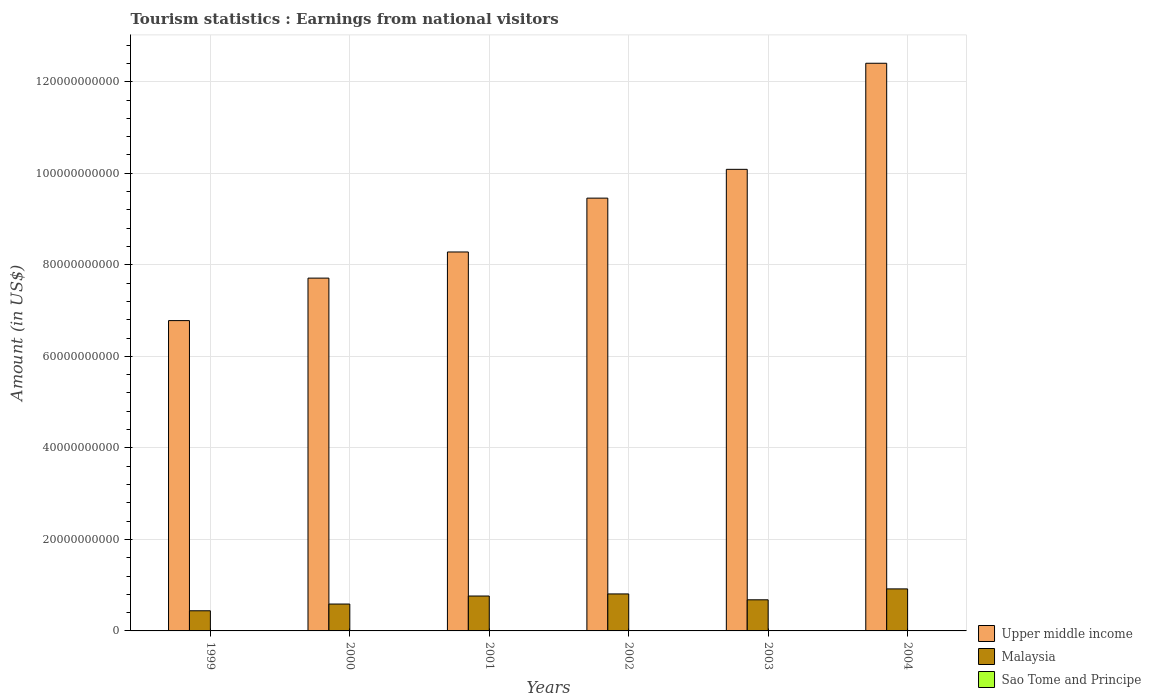How many different coloured bars are there?
Keep it short and to the point. 3. How many groups of bars are there?
Your response must be concise. 6. Are the number of bars per tick equal to the number of legend labels?
Provide a succinct answer. Yes. How many bars are there on the 6th tick from the left?
Ensure brevity in your answer.  3. What is the label of the 6th group of bars from the left?
Give a very brief answer. 2004. What is the earnings from national visitors in Upper middle income in 2000?
Offer a very short reply. 7.71e+1. Across all years, what is the maximum earnings from national visitors in Sao Tome and Principe?
Make the answer very short. 9.90e+06. Across all years, what is the minimum earnings from national visitors in Malaysia?
Your answer should be compact. 4.40e+09. What is the total earnings from national visitors in Malaysia in the graph?
Keep it short and to the point. 4.20e+1. What is the difference between the earnings from national visitors in Sao Tome and Principe in 2001 and that in 2003?
Make the answer very short. -1.20e+06. What is the difference between the earnings from national visitors in Sao Tome and Principe in 2000 and the earnings from national visitors in Upper middle income in 2002?
Your answer should be compact. -9.46e+1. What is the average earnings from national visitors in Upper middle income per year?
Provide a short and direct response. 9.12e+1. In the year 1999, what is the difference between the earnings from national visitors in Sao Tome and Principe and earnings from national visitors in Upper middle income?
Offer a very short reply. -6.78e+1. In how many years, is the earnings from national visitors in Upper middle income greater than 52000000000 US$?
Offer a very short reply. 6. What is the ratio of the earnings from national visitors in Upper middle income in 2001 to that in 2004?
Your answer should be very brief. 0.67. What is the difference between the highest and the second highest earnings from national visitors in Upper middle income?
Provide a succinct answer. 2.32e+1. What is the difference between the highest and the lowest earnings from national visitors in Malaysia?
Your response must be concise. 4.78e+09. In how many years, is the earnings from national visitors in Upper middle income greater than the average earnings from national visitors in Upper middle income taken over all years?
Ensure brevity in your answer.  3. What does the 2nd bar from the left in 2001 represents?
Give a very brief answer. Malaysia. What does the 1st bar from the right in 2000 represents?
Offer a very short reply. Sao Tome and Principe. Are all the bars in the graph horizontal?
Keep it short and to the point. No. Does the graph contain grids?
Keep it short and to the point. Yes. What is the title of the graph?
Offer a very short reply. Tourism statistics : Earnings from national visitors. What is the label or title of the X-axis?
Make the answer very short. Years. What is the Amount (in US$) in Upper middle income in 1999?
Keep it short and to the point. 6.78e+1. What is the Amount (in US$) in Malaysia in 1999?
Keep it short and to the point. 4.40e+09. What is the Amount (in US$) of Sao Tome and Principe in 1999?
Ensure brevity in your answer.  9.20e+06. What is the Amount (in US$) of Upper middle income in 2000?
Keep it short and to the point. 7.71e+1. What is the Amount (in US$) of Malaysia in 2000?
Ensure brevity in your answer.  5.87e+09. What is the Amount (in US$) of Sao Tome and Principe in 2000?
Offer a terse response. 9.90e+06. What is the Amount (in US$) of Upper middle income in 2001?
Your answer should be compact. 8.28e+1. What is the Amount (in US$) of Malaysia in 2001?
Provide a succinct answer. 7.63e+09. What is the Amount (in US$) in Sao Tome and Principe in 2001?
Your response must be concise. 6.20e+06. What is the Amount (in US$) of Upper middle income in 2002?
Offer a very short reply. 9.46e+1. What is the Amount (in US$) of Malaysia in 2002?
Ensure brevity in your answer.  8.08e+09. What is the Amount (in US$) of Sao Tome and Principe in 2002?
Ensure brevity in your answer.  6.90e+06. What is the Amount (in US$) in Upper middle income in 2003?
Ensure brevity in your answer.  1.01e+11. What is the Amount (in US$) in Malaysia in 2003?
Make the answer very short. 6.80e+09. What is the Amount (in US$) of Sao Tome and Principe in 2003?
Give a very brief answer. 7.40e+06. What is the Amount (in US$) in Upper middle income in 2004?
Keep it short and to the point. 1.24e+11. What is the Amount (in US$) of Malaysia in 2004?
Provide a short and direct response. 9.18e+09. What is the Amount (in US$) in Sao Tome and Principe in 2004?
Your answer should be very brief. 7.70e+06. Across all years, what is the maximum Amount (in US$) of Upper middle income?
Provide a succinct answer. 1.24e+11. Across all years, what is the maximum Amount (in US$) of Malaysia?
Your answer should be compact. 9.18e+09. Across all years, what is the maximum Amount (in US$) in Sao Tome and Principe?
Ensure brevity in your answer.  9.90e+06. Across all years, what is the minimum Amount (in US$) in Upper middle income?
Provide a short and direct response. 6.78e+1. Across all years, what is the minimum Amount (in US$) in Malaysia?
Give a very brief answer. 4.40e+09. Across all years, what is the minimum Amount (in US$) in Sao Tome and Principe?
Offer a very short reply. 6.20e+06. What is the total Amount (in US$) of Upper middle income in the graph?
Offer a very short reply. 5.47e+11. What is the total Amount (in US$) of Malaysia in the graph?
Your answer should be very brief. 4.20e+1. What is the total Amount (in US$) in Sao Tome and Principe in the graph?
Provide a short and direct response. 4.73e+07. What is the difference between the Amount (in US$) in Upper middle income in 1999 and that in 2000?
Keep it short and to the point. -9.29e+09. What is the difference between the Amount (in US$) in Malaysia in 1999 and that in 2000?
Make the answer very short. -1.47e+09. What is the difference between the Amount (in US$) in Sao Tome and Principe in 1999 and that in 2000?
Offer a terse response. -7.00e+05. What is the difference between the Amount (in US$) in Upper middle income in 1999 and that in 2001?
Your answer should be compact. -1.50e+1. What is the difference between the Amount (in US$) in Malaysia in 1999 and that in 2001?
Keep it short and to the point. -3.22e+09. What is the difference between the Amount (in US$) of Sao Tome and Principe in 1999 and that in 2001?
Provide a short and direct response. 3.00e+06. What is the difference between the Amount (in US$) of Upper middle income in 1999 and that in 2002?
Make the answer very short. -2.68e+1. What is the difference between the Amount (in US$) in Malaysia in 1999 and that in 2002?
Give a very brief answer. -3.68e+09. What is the difference between the Amount (in US$) in Sao Tome and Principe in 1999 and that in 2002?
Your answer should be very brief. 2.30e+06. What is the difference between the Amount (in US$) of Upper middle income in 1999 and that in 2003?
Keep it short and to the point. -3.31e+1. What is the difference between the Amount (in US$) in Malaysia in 1999 and that in 2003?
Provide a short and direct response. -2.40e+09. What is the difference between the Amount (in US$) in Sao Tome and Principe in 1999 and that in 2003?
Offer a very short reply. 1.80e+06. What is the difference between the Amount (in US$) in Upper middle income in 1999 and that in 2004?
Keep it short and to the point. -5.62e+1. What is the difference between the Amount (in US$) in Malaysia in 1999 and that in 2004?
Provide a short and direct response. -4.78e+09. What is the difference between the Amount (in US$) of Sao Tome and Principe in 1999 and that in 2004?
Your answer should be very brief. 1.50e+06. What is the difference between the Amount (in US$) in Upper middle income in 2000 and that in 2001?
Provide a short and direct response. -5.71e+09. What is the difference between the Amount (in US$) in Malaysia in 2000 and that in 2001?
Give a very brief answer. -1.75e+09. What is the difference between the Amount (in US$) of Sao Tome and Principe in 2000 and that in 2001?
Provide a short and direct response. 3.70e+06. What is the difference between the Amount (in US$) of Upper middle income in 2000 and that in 2002?
Your answer should be compact. -1.75e+1. What is the difference between the Amount (in US$) of Malaysia in 2000 and that in 2002?
Your answer should be compact. -2.21e+09. What is the difference between the Amount (in US$) in Upper middle income in 2000 and that in 2003?
Your response must be concise. -2.38e+1. What is the difference between the Amount (in US$) of Malaysia in 2000 and that in 2003?
Offer a very short reply. -9.26e+08. What is the difference between the Amount (in US$) of Sao Tome and Principe in 2000 and that in 2003?
Offer a very short reply. 2.50e+06. What is the difference between the Amount (in US$) of Upper middle income in 2000 and that in 2004?
Keep it short and to the point. -4.70e+1. What is the difference between the Amount (in US$) in Malaysia in 2000 and that in 2004?
Give a very brief answer. -3.31e+09. What is the difference between the Amount (in US$) in Sao Tome and Principe in 2000 and that in 2004?
Ensure brevity in your answer.  2.20e+06. What is the difference between the Amount (in US$) in Upper middle income in 2001 and that in 2002?
Provide a succinct answer. -1.18e+1. What is the difference between the Amount (in US$) of Malaysia in 2001 and that in 2002?
Ensure brevity in your answer.  -4.57e+08. What is the difference between the Amount (in US$) of Sao Tome and Principe in 2001 and that in 2002?
Keep it short and to the point. -7.00e+05. What is the difference between the Amount (in US$) of Upper middle income in 2001 and that in 2003?
Offer a very short reply. -1.81e+1. What is the difference between the Amount (in US$) in Malaysia in 2001 and that in 2003?
Your answer should be very brief. 8.28e+08. What is the difference between the Amount (in US$) of Sao Tome and Principe in 2001 and that in 2003?
Your answer should be compact. -1.20e+06. What is the difference between the Amount (in US$) in Upper middle income in 2001 and that in 2004?
Ensure brevity in your answer.  -4.12e+1. What is the difference between the Amount (in US$) of Malaysia in 2001 and that in 2004?
Provide a short and direct response. -1.56e+09. What is the difference between the Amount (in US$) in Sao Tome and Principe in 2001 and that in 2004?
Your answer should be compact. -1.50e+06. What is the difference between the Amount (in US$) in Upper middle income in 2002 and that in 2003?
Your response must be concise. -6.29e+09. What is the difference between the Amount (in US$) of Malaysia in 2002 and that in 2003?
Offer a terse response. 1.28e+09. What is the difference between the Amount (in US$) in Sao Tome and Principe in 2002 and that in 2003?
Offer a very short reply. -5.00e+05. What is the difference between the Amount (in US$) of Upper middle income in 2002 and that in 2004?
Ensure brevity in your answer.  -2.95e+1. What is the difference between the Amount (in US$) of Malaysia in 2002 and that in 2004?
Ensure brevity in your answer.  -1.10e+09. What is the difference between the Amount (in US$) in Sao Tome and Principe in 2002 and that in 2004?
Provide a succinct answer. -8.00e+05. What is the difference between the Amount (in US$) in Upper middle income in 2003 and that in 2004?
Your answer should be very brief. -2.32e+1. What is the difference between the Amount (in US$) of Malaysia in 2003 and that in 2004?
Make the answer very short. -2.38e+09. What is the difference between the Amount (in US$) of Sao Tome and Principe in 2003 and that in 2004?
Your answer should be very brief. -3.00e+05. What is the difference between the Amount (in US$) in Upper middle income in 1999 and the Amount (in US$) in Malaysia in 2000?
Provide a succinct answer. 6.19e+1. What is the difference between the Amount (in US$) in Upper middle income in 1999 and the Amount (in US$) in Sao Tome and Principe in 2000?
Your answer should be compact. 6.78e+1. What is the difference between the Amount (in US$) in Malaysia in 1999 and the Amount (in US$) in Sao Tome and Principe in 2000?
Offer a terse response. 4.39e+09. What is the difference between the Amount (in US$) of Upper middle income in 1999 and the Amount (in US$) of Malaysia in 2001?
Your answer should be compact. 6.02e+1. What is the difference between the Amount (in US$) in Upper middle income in 1999 and the Amount (in US$) in Sao Tome and Principe in 2001?
Your response must be concise. 6.78e+1. What is the difference between the Amount (in US$) of Malaysia in 1999 and the Amount (in US$) of Sao Tome and Principe in 2001?
Give a very brief answer. 4.40e+09. What is the difference between the Amount (in US$) in Upper middle income in 1999 and the Amount (in US$) in Malaysia in 2002?
Your answer should be very brief. 5.97e+1. What is the difference between the Amount (in US$) in Upper middle income in 1999 and the Amount (in US$) in Sao Tome and Principe in 2002?
Make the answer very short. 6.78e+1. What is the difference between the Amount (in US$) of Malaysia in 1999 and the Amount (in US$) of Sao Tome and Principe in 2002?
Your answer should be compact. 4.40e+09. What is the difference between the Amount (in US$) in Upper middle income in 1999 and the Amount (in US$) in Malaysia in 2003?
Offer a very short reply. 6.10e+1. What is the difference between the Amount (in US$) of Upper middle income in 1999 and the Amount (in US$) of Sao Tome and Principe in 2003?
Your response must be concise. 6.78e+1. What is the difference between the Amount (in US$) in Malaysia in 1999 and the Amount (in US$) in Sao Tome and Principe in 2003?
Make the answer very short. 4.40e+09. What is the difference between the Amount (in US$) of Upper middle income in 1999 and the Amount (in US$) of Malaysia in 2004?
Ensure brevity in your answer.  5.86e+1. What is the difference between the Amount (in US$) of Upper middle income in 1999 and the Amount (in US$) of Sao Tome and Principe in 2004?
Your answer should be very brief. 6.78e+1. What is the difference between the Amount (in US$) of Malaysia in 1999 and the Amount (in US$) of Sao Tome and Principe in 2004?
Your answer should be very brief. 4.40e+09. What is the difference between the Amount (in US$) of Upper middle income in 2000 and the Amount (in US$) of Malaysia in 2001?
Provide a succinct answer. 6.95e+1. What is the difference between the Amount (in US$) of Upper middle income in 2000 and the Amount (in US$) of Sao Tome and Principe in 2001?
Provide a succinct answer. 7.71e+1. What is the difference between the Amount (in US$) in Malaysia in 2000 and the Amount (in US$) in Sao Tome and Principe in 2001?
Give a very brief answer. 5.87e+09. What is the difference between the Amount (in US$) of Upper middle income in 2000 and the Amount (in US$) of Malaysia in 2002?
Offer a very short reply. 6.90e+1. What is the difference between the Amount (in US$) in Upper middle income in 2000 and the Amount (in US$) in Sao Tome and Principe in 2002?
Give a very brief answer. 7.71e+1. What is the difference between the Amount (in US$) of Malaysia in 2000 and the Amount (in US$) of Sao Tome and Principe in 2002?
Your answer should be compact. 5.87e+09. What is the difference between the Amount (in US$) in Upper middle income in 2000 and the Amount (in US$) in Malaysia in 2003?
Your response must be concise. 7.03e+1. What is the difference between the Amount (in US$) of Upper middle income in 2000 and the Amount (in US$) of Sao Tome and Principe in 2003?
Your answer should be very brief. 7.71e+1. What is the difference between the Amount (in US$) in Malaysia in 2000 and the Amount (in US$) in Sao Tome and Principe in 2003?
Offer a terse response. 5.87e+09. What is the difference between the Amount (in US$) of Upper middle income in 2000 and the Amount (in US$) of Malaysia in 2004?
Your response must be concise. 6.79e+1. What is the difference between the Amount (in US$) of Upper middle income in 2000 and the Amount (in US$) of Sao Tome and Principe in 2004?
Make the answer very short. 7.71e+1. What is the difference between the Amount (in US$) of Malaysia in 2000 and the Amount (in US$) of Sao Tome and Principe in 2004?
Your answer should be very brief. 5.87e+09. What is the difference between the Amount (in US$) in Upper middle income in 2001 and the Amount (in US$) in Malaysia in 2002?
Your answer should be compact. 7.47e+1. What is the difference between the Amount (in US$) in Upper middle income in 2001 and the Amount (in US$) in Sao Tome and Principe in 2002?
Offer a very short reply. 8.28e+1. What is the difference between the Amount (in US$) in Malaysia in 2001 and the Amount (in US$) in Sao Tome and Principe in 2002?
Provide a succinct answer. 7.62e+09. What is the difference between the Amount (in US$) in Upper middle income in 2001 and the Amount (in US$) in Malaysia in 2003?
Offer a terse response. 7.60e+1. What is the difference between the Amount (in US$) in Upper middle income in 2001 and the Amount (in US$) in Sao Tome and Principe in 2003?
Provide a succinct answer. 8.28e+1. What is the difference between the Amount (in US$) of Malaysia in 2001 and the Amount (in US$) of Sao Tome and Principe in 2003?
Your answer should be compact. 7.62e+09. What is the difference between the Amount (in US$) of Upper middle income in 2001 and the Amount (in US$) of Malaysia in 2004?
Give a very brief answer. 7.36e+1. What is the difference between the Amount (in US$) in Upper middle income in 2001 and the Amount (in US$) in Sao Tome and Principe in 2004?
Provide a short and direct response. 8.28e+1. What is the difference between the Amount (in US$) of Malaysia in 2001 and the Amount (in US$) of Sao Tome and Principe in 2004?
Provide a short and direct response. 7.62e+09. What is the difference between the Amount (in US$) in Upper middle income in 2002 and the Amount (in US$) in Malaysia in 2003?
Offer a very short reply. 8.78e+1. What is the difference between the Amount (in US$) of Upper middle income in 2002 and the Amount (in US$) of Sao Tome and Principe in 2003?
Ensure brevity in your answer.  9.46e+1. What is the difference between the Amount (in US$) of Malaysia in 2002 and the Amount (in US$) of Sao Tome and Principe in 2003?
Make the answer very short. 8.08e+09. What is the difference between the Amount (in US$) of Upper middle income in 2002 and the Amount (in US$) of Malaysia in 2004?
Provide a succinct answer. 8.54e+1. What is the difference between the Amount (in US$) in Upper middle income in 2002 and the Amount (in US$) in Sao Tome and Principe in 2004?
Provide a short and direct response. 9.46e+1. What is the difference between the Amount (in US$) in Malaysia in 2002 and the Amount (in US$) in Sao Tome and Principe in 2004?
Offer a terse response. 8.08e+09. What is the difference between the Amount (in US$) in Upper middle income in 2003 and the Amount (in US$) in Malaysia in 2004?
Keep it short and to the point. 9.17e+1. What is the difference between the Amount (in US$) in Upper middle income in 2003 and the Amount (in US$) in Sao Tome and Principe in 2004?
Provide a succinct answer. 1.01e+11. What is the difference between the Amount (in US$) of Malaysia in 2003 and the Amount (in US$) of Sao Tome and Principe in 2004?
Offer a very short reply. 6.79e+09. What is the average Amount (in US$) in Upper middle income per year?
Provide a short and direct response. 9.12e+1. What is the average Amount (in US$) in Malaysia per year?
Your response must be concise. 6.99e+09. What is the average Amount (in US$) of Sao Tome and Principe per year?
Your answer should be very brief. 7.88e+06. In the year 1999, what is the difference between the Amount (in US$) of Upper middle income and Amount (in US$) of Malaysia?
Keep it short and to the point. 6.34e+1. In the year 1999, what is the difference between the Amount (in US$) in Upper middle income and Amount (in US$) in Sao Tome and Principe?
Provide a short and direct response. 6.78e+1. In the year 1999, what is the difference between the Amount (in US$) of Malaysia and Amount (in US$) of Sao Tome and Principe?
Offer a terse response. 4.39e+09. In the year 2000, what is the difference between the Amount (in US$) of Upper middle income and Amount (in US$) of Malaysia?
Ensure brevity in your answer.  7.12e+1. In the year 2000, what is the difference between the Amount (in US$) in Upper middle income and Amount (in US$) in Sao Tome and Principe?
Offer a very short reply. 7.71e+1. In the year 2000, what is the difference between the Amount (in US$) of Malaysia and Amount (in US$) of Sao Tome and Principe?
Make the answer very short. 5.86e+09. In the year 2001, what is the difference between the Amount (in US$) in Upper middle income and Amount (in US$) in Malaysia?
Give a very brief answer. 7.52e+1. In the year 2001, what is the difference between the Amount (in US$) of Upper middle income and Amount (in US$) of Sao Tome and Principe?
Keep it short and to the point. 8.28e+1. In the year 2001, what is the difference between the Amount (in US$) of Malaysia and Amount (in US$) of Sao Tome and Principe?
Offer a very short reply. 7.62e+09. In the year 2002, what is the difference between the Amount (in US$) of Upper middle income and Amount (in US$) of Malaysia?
Provide a short and direct response. 8.65e+1. In the year 2002, what is the difference between the Amount (in US$) in Upper middle income and Amount (in US$) in Sao Tome and Principe?
Keep it short and to the point. 9.46e+1. In the year 2002, what is the difference between the Amount (in US$) in Malaysia and Amount (in US$) in Sao Tome and Principe?
Make the answer very short. 8.08e+09. In the year 2003, what is the difference between the Amount (in US$) in Upper middle income and Amount (in US$) in Malaysia?
Your answer should be very brief. 9.41e+1. In the year 2003, what is the difference between the Amount (in US$) of Upper middle income and Amount (in US$) of Sao Tome and Principe?
Make the answer very short. 1.01e+11. In the year 2003, what is the difference between the Amount (in US$) in Malaysia and Amount (in US$) in Sao Tome and Principe?
Make the answer very short. 6.79e+09. In the year 2004, what is the difference between the Amount (in US$) of Upper middle income and Amount (in US$) of Malaysia?
Offer a very short reply. 1.15e+11. In the year 2004, what is the difference between the Amount (in US$) in Upper middle income and Amount (in US$) in Sao Tome and Principe?
Keep it short and to the point. 1.24e+11. In the year 2004, what is the difference between the Amount (in US$) in Malaysia and Amount (in US$) in Sao Tome and Principe?
Give a very brief answer. 9.18e+09. What is the ratio of the Amount (in US$) of Upper middle income in 1999 to that in 2000?
Give a very brief answer. 0.88. What is the ratio of the Amount (in US$) of Malaysia in 1999 to that in 2000?
Offer a terse response. 0.75. What is the ratio of the Amount (in US$) of Sao Tome and Principe in 1999 to that in 2000?
Make the answer very short. 0.93. What is the ratio of the Amount (in US$) of Upper middle income in 1999 to that in 2001?
Offer a very short reply. 0.82. What is the ratio of the Amount (in US$) of Malaysia in 1999 to that in 2001?
Offer a terse response. 0.58. What is the ratio of the Amount (in US$) in Sao Tome and Principe in 1999 to that in 2001?
Offer a terse response. 1.48. What is the ratio of the Amount (in US$) in Upper middle income in 1999 to that in 2002?
Your answer should be very brief. 0.72. What is the ratio of the Amount (in US$) of Malaysia in 1999 to that in 2002?
Offer a very short reply. 0.54. What is the ratio of the Amount (in US$) of Upper middle income in 1999 to that in 2003?
Provide a short and direct response. 0.67. What is the ratio of the Amount (in US$) of Malaysia in 1999 to that in 2003?
Keep it short and to the point. 0.65. What is the ratio of the Amount (in US$) of Sao Tome and Principe in 1999 to that in 2003?
Your response must be concise. 1.24. What is the ratio of the Amount (in US$) of Upper middle income in 1999 to that in 2004?
Keep it short and to the point. 0.55. What is the ratio of the Amount (in US$) in Malaysia in 1999 to that in 2004?
Your answer should be compact. 0.48. What is the ratio of the Amount (in US$) in Sao Tome and Principe in 1999 to that in 2004?
Ensure brevity in your answer.  1.19. What is the ratio of the Amount (in US$) of Malaysia in 2000 to that in 2001?
Make the answer very short. 0.77. What is the ratio of the Amount (in US$) of Sao Tome and Principe in 2000 to that in 2001?
Provide a succinct answer. 1.6. What is the ratio of the Amount (in US$) of Upper middle income in 2000 to that in 2002?
Your answer should be compact. 0.82. What is the ratio of the Amount (in US$) of Malaysia in 2000 to that in 2002?
Offer a very short reply. 0.73. What is the ratio of the Amount (in US$) in Sao Tome and Principe in 2000 to that in 2002?
Your answer should be very brief. 1.43. What is the ratio of the Amount (in US$) in Upper middle income in 2000 to that in 2003?
Provide a succinct answer. 0.76. What is the ratio of the Amount (in US$) of Malaysia in 2000 to that in 2003?
Give a very brief answer. 0.86. What is the ratio of the Amount (in US$) in Sao Tome and Principe in 2000 to that in 2003?
Provide a succinct answer. 1.34. What is the ratio of the Amount (in US$) in Upper middle income in 2000 to that in 2004?
Offer a very short reply. 0.62. What is the ratio of the Amount (in US$) of Malaysia in 2000 to that in 2004?
Offer a very short reply. 0.64. What is the ratio of the Amount (in US$) of Upper middle income in 2001 to that in 2002?
Give a very brief answer. 0.88. What is the ratio of the Amount (in US$) in Malaysia in 2001 to that in 2002?
Make the answer very short. 0.94. What is the ratio of the Amount (in US$) of Sao Tome and Principe in 2001 to that in 2002?
Give a very brief answer. 0.9. What is the ratio of the Amount (in US$) of Upper middle income in 2001 to that in 2003?
Keep it short and to the point. 0.82. What is the ratio of the Amount (in US$) of Malaysia in 2001 to that in 2003?
Make the answer very short. 1.12. What is the ratio of the Amount (in US$) in Sao Tome and Principe in 2001 to that in 2003?
Keep it short and to the point. 0.84. What is the ratio of the Amount (in US$) in Upper middle income in 2001 to that in 2004?
Your answer should be compact. 0.67. What is the ratio of the Amount (in US$) in Malaysia in 2001 to that in 2004?
Ensure brevity in your answer.  0.83. What is the ratio of the Amount (in US$) in Sao Tome and Principe in 2001 to that in 2004?
Keep it short and to the point. 0.81. What is the ratio of the Amount (in US$) of Upper middle income in 2002 to that in 2003?
Offer a terse response. 0.94. What is the ratio of the Amount (in US$) in Malaysia in 2002 to that in 2003?
Give a very brief answer. 1.19. What is the ratio of the Amount (in US$) of Sao Tome and Principe in 2002 to that in 2003?
Provide a short and direct response. 0.93. What is the ratio of the Amount (in US$) in Upper middle income in 2002 to that in 2004?
Your answer should be very brief. 0.76. What is the ratio of the Amount (in US$) of Malaysia in 2002 to that in 2004?
Provide a short and direct response. 0.88. What is the ratio of the Amount (in US$) in Sao Tome and Principe in 2002 to that in 2004?
Provide a succinct answer. 0.9. What is the ratio of the Amount (in US$) of Upper middle income in 2003 to that in 2004?
Make the answer very short. 0.81. What is the ratio of the Amount (in US$) of Malaysia in 2003 to that in 2004?
Your answer should be very brief. 0.74. What is the ratio of the Amount (in US$) of Sao Tome and Principe in 2003 to that in 2004?
Provide a short and direct response. 0.96. What is the difference between the highest and the second highest Amount (in US$) of Upper middle income?
Make the answer very short. 2.32e+1. What is the difference between the highest and the second highest Amount (in US$) of Malaysia?
Offer a terse response. 1.10e+09. What is the difference between the highest and the second highest Amount (in US$) in Sao Tome and Principe?
Offer a terse response. 7.00e+05. What is the difference between the highest and the lowest Amount (in US$) of Upper middle income?
Provide a short and direct response. 5.62e+1. What is the difference between the highest and the lowest Amount (in US$) of Malaysia?
Offer a terse response. 4.78e+09. What is the difference between the highest and the lowest Amount (in US$) of Sao Tome and Principe?
Ensure brevity in your answer.  3.70e+06. 